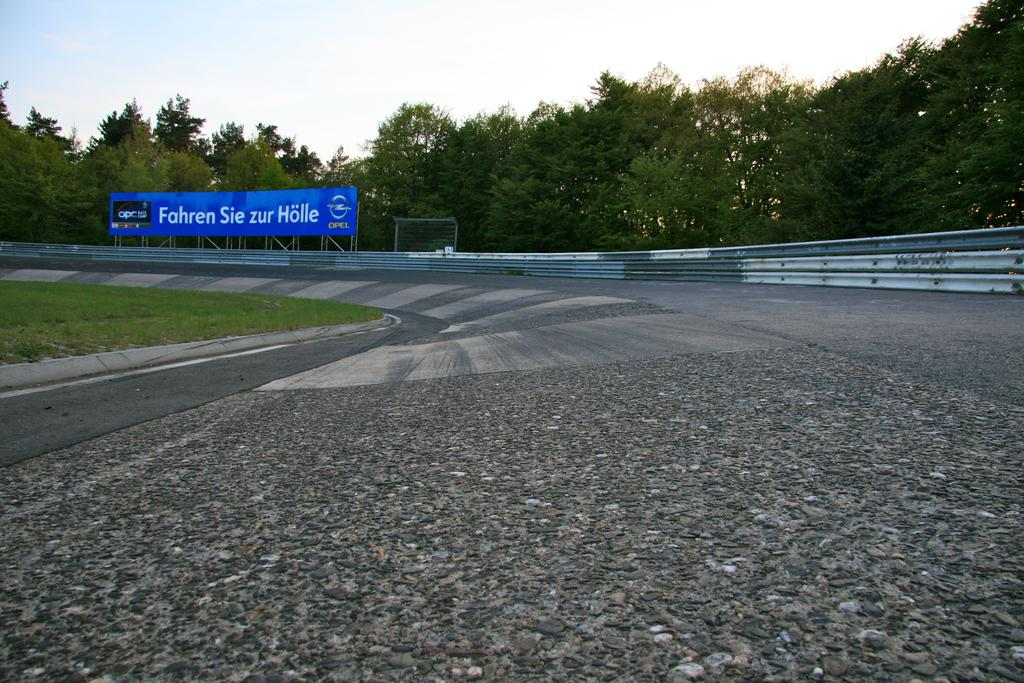Provide a one-sentence caption for the provided image. Low perspective of a race track looking forward to a curve with a blue billboard featuring an advertisement written in white. 